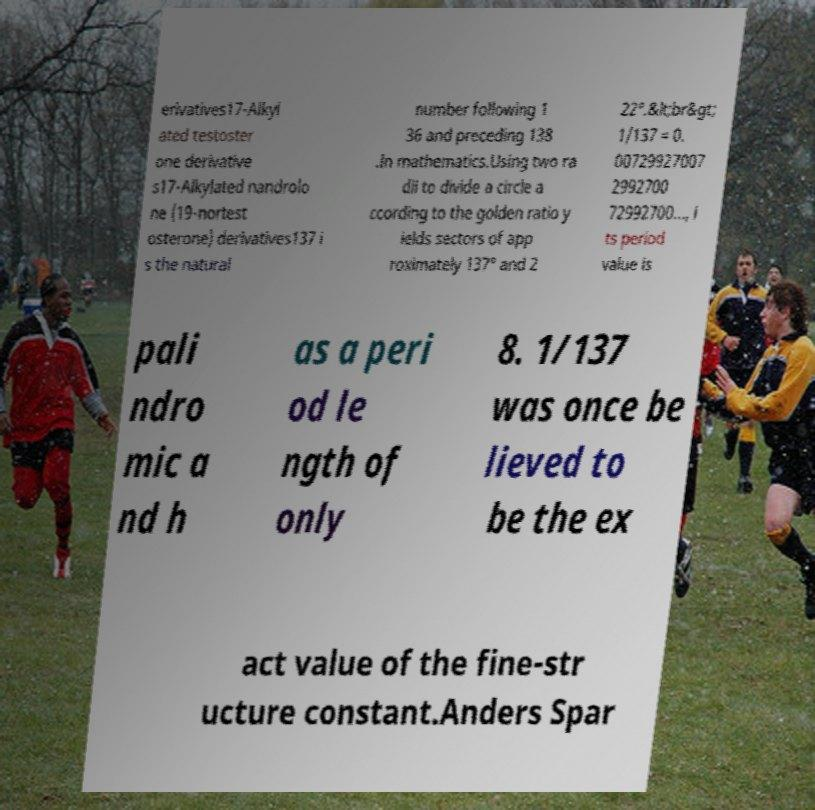Please read and relay the text visible in this image. What does it say? erivatives17-Alkyl ated testoster one derivative s17-Alkylated nandrolo ne (19-nortest osterone) derivatives137 i s the natural number following 1 36 and preceding 138 .In mathematics.Using two ra dii to divide a circle a ccording to the golden ratio y ields sectors of app roximately 137° and 2 22°.&lt;br&gt; 1/137 = 0. 00729927007 2992700 72992700..., i ts period value is pali ndro mic a nd h as a peri od le ngth of only 8. 1/137 was once be lieved to be the ex act value of the fine-str ucture constant.Anders Spar 